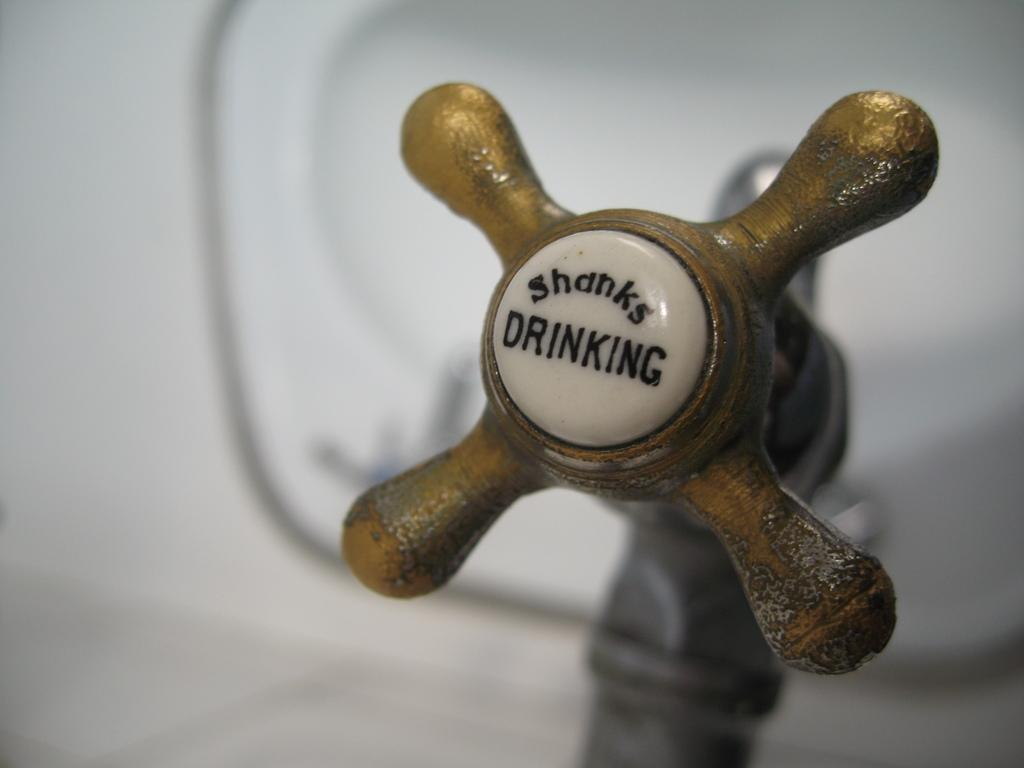What is the main object in the image? There is a tap in the image. What color or design elements are present on the tap? The tap has goldfish-colored elements. What is the color of the background in the image? The background of the image is white. Can you describe the argument between the goldfish and the dock in the image? There is no argument between the goldfish and the dock in the image, as neither a goldfish nor a dock is present. 